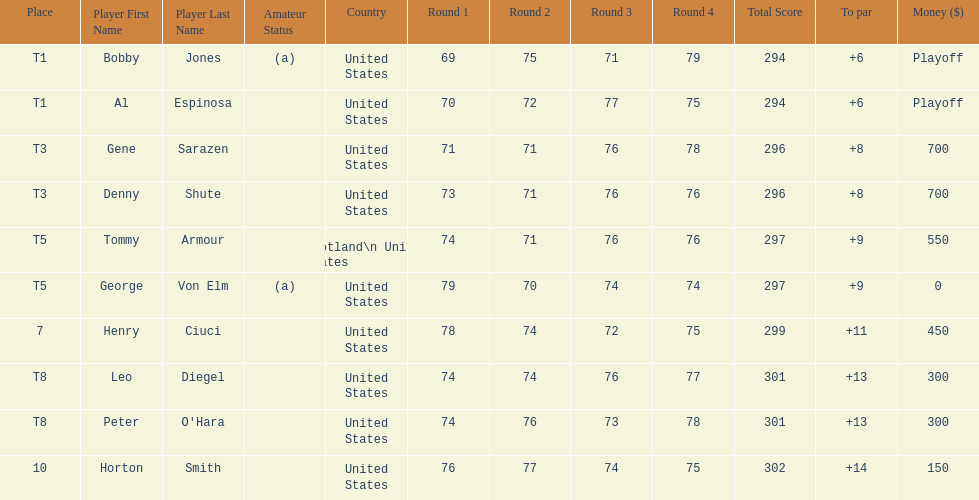Who finished next after bobby jones and al espinosa? Gene Sarazen, Denny Shute. 